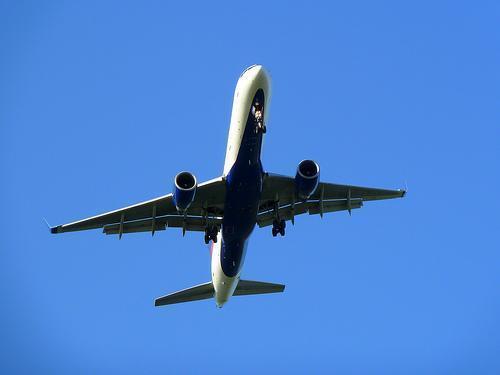How many engines does the plane have?
Give a very brief answer. 2. 